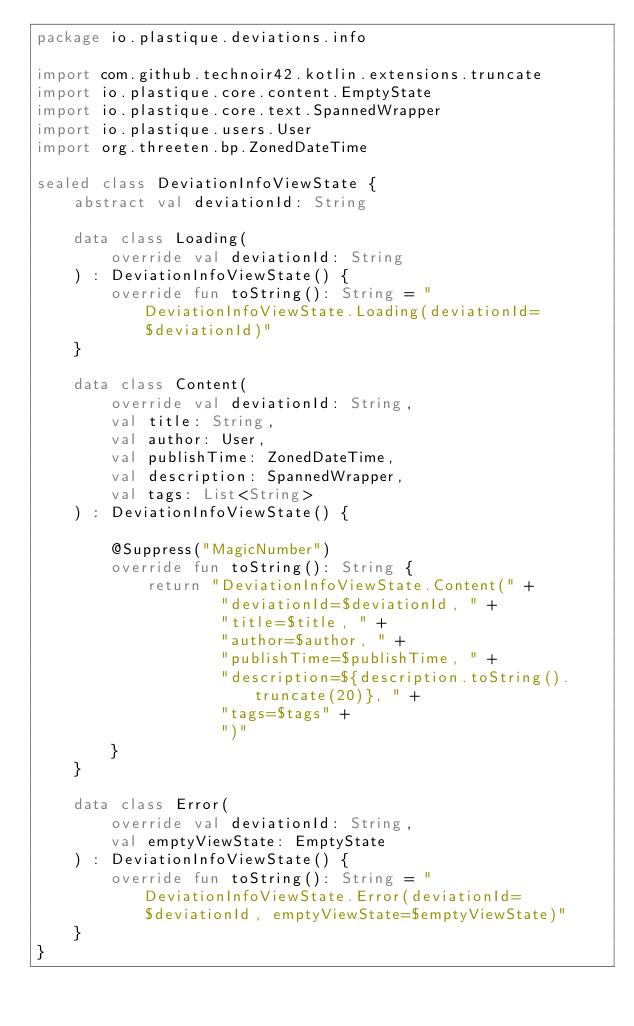<code> <loc_0><loc_0><loc_500><loc_500><_Kotlin_>package io.plastique.deviations.info

import com.github.technoir42.kotlin.extensions.truncate
import io.plastique.core.content.EmptyState
import io.plastique.core.text.SpannedWrapper
import io.plastique.users.User
import org.threeten.bp.ZonedDateTime

sealed class DeviationInfoViewState {
    abstract val deviationId: String

    data class Loading(
        override val deviationId: String
    ) : DeviationInfoViewState() {
        override fun toString(): String = "DeviationInfoViewState.Loading(deviationId=$deviationId)"
    }

    data class Content(
        override val deviationId: String,
        val title: String,
        val author: User,
        val publishTime: ZonedDateTime,
        val description: SpannedWrapper,
        val tags: List<String>
    ) : DeviationInfoViewState() {

        @Suppress("MagicNumber")
        override fun toString(): String {
            return "DeviationInfoViewState.Content(" +
                    "deviationId=$deviationId, " +
                    "title=$title, " +
                    "author=$author, " +
                    "publishTime=$publishTime, " +
                    "description=${description.toString().truncate(20)}, " +
                    "tags=$tags" +
                    ")"
        }
    }

    data class Error(
        override val deviationId: String,
        val emptyViewState: EmptyState
    ) : DeviationInfoViewState() {
        override fun toString(): String = "DeviationInfoViewState.Error(deviationId=$deviationId, emptyViewState=$emptyViewState)"
    }
}
</code> 